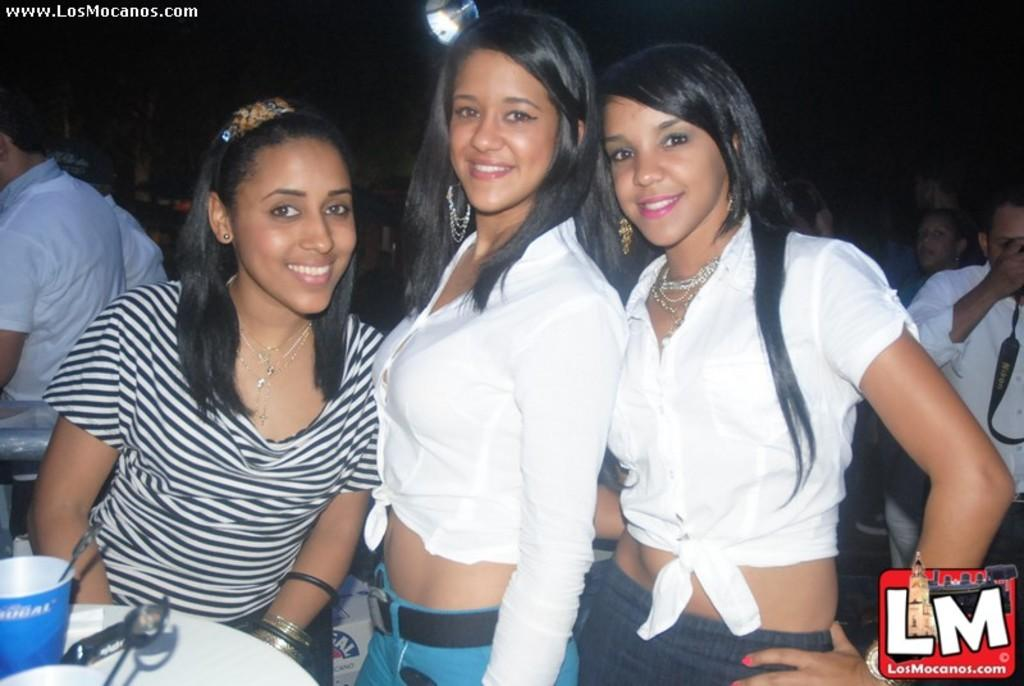<image>
Present a compact description of the photo's key features. Three women sit at a table for a picture and it has LM on the lower right corner. 